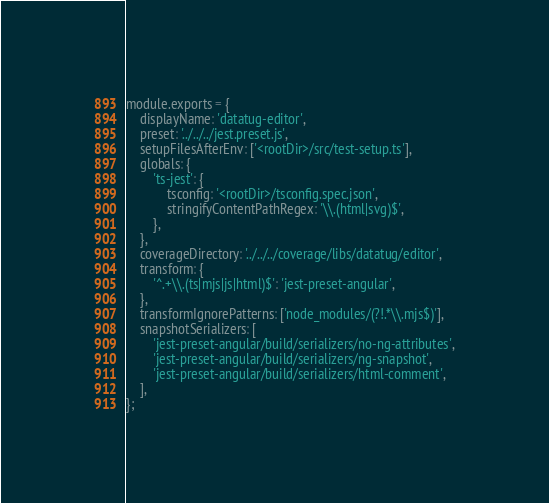Convert code to text. <code><loc_0><loc_0><loc_500><loc_500><_JavaScript_>module.exports = {
	displayName: 'datatug-editor',
	preset: '../../../jest.preset.js',
	setupFilesAfterEnv: ['<rootDir>/src/test-setup.ts'],
	globals: {
		'ts-jest': {
			tsconfig: '<rootDir>/tsconfig.spec.json',
			stringifyContentPathRegex: '\\.(html|svg)$',
		},
	},
	coverageDirectory: '../../../coverage/libs/datatug/editor',
	transform: {
		'^.+\\.(ts|mjs|js|html)$': 'jest-preset-angular',
	},
	transformIgnorePatterns: ['node_modules/(?!.*\\.mjs$)'],
	snapshotSerializers: [
		'jest-preset-angular/build/serializers/no-ng-attributes',
		'jest-preset-angular/build/serializers/ng-snapshot',
		'jest-preset-angular/build/serializers/html-comment',
	],
};
</code> 